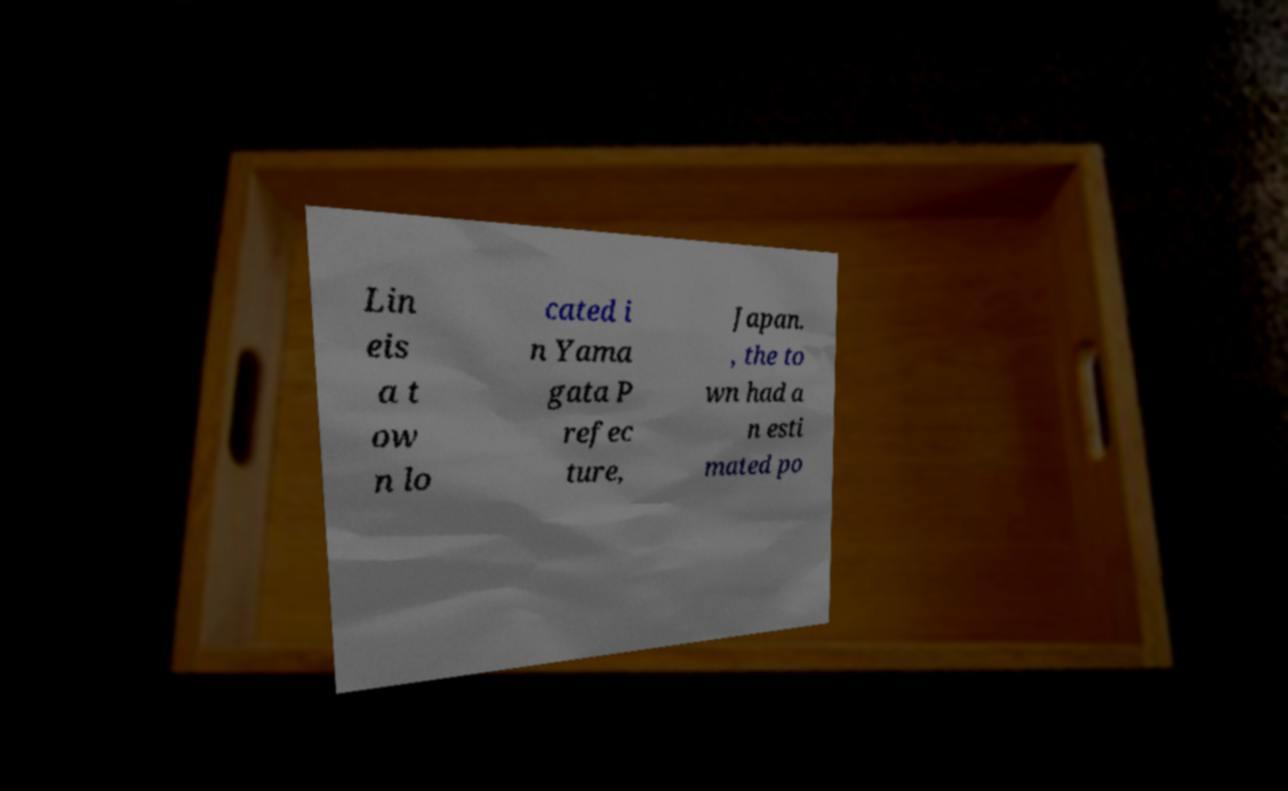Can you read and provide the text displayed in the image?This photo seems to have some interesting text. Can you extract and type it out for me? Lin eis a t ow n lo cated i n Yama gata P refec ture, Japan. , the to wn had a n esti mated po 